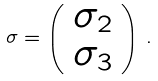Convert formula to latex. <formula><loc_0><loc_0><loc_500><loc_500>\sigma = \left ( \begin{array} { c } \sigma _ { 2 } \\ \sigma _ { 3 } \\ \end{array} \right ) \, .</formula> 